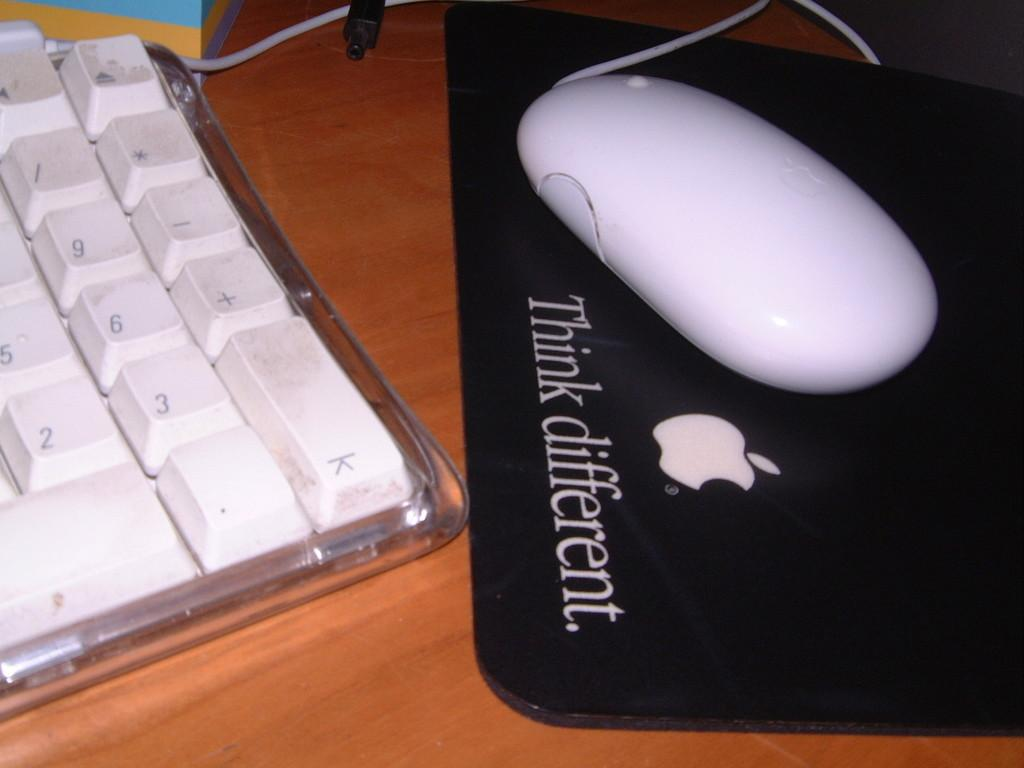<image>
Describe the image concisely. A wired, computer mouse is sitting on a mouse pad with an apple symbol on it that says think different underneath. 